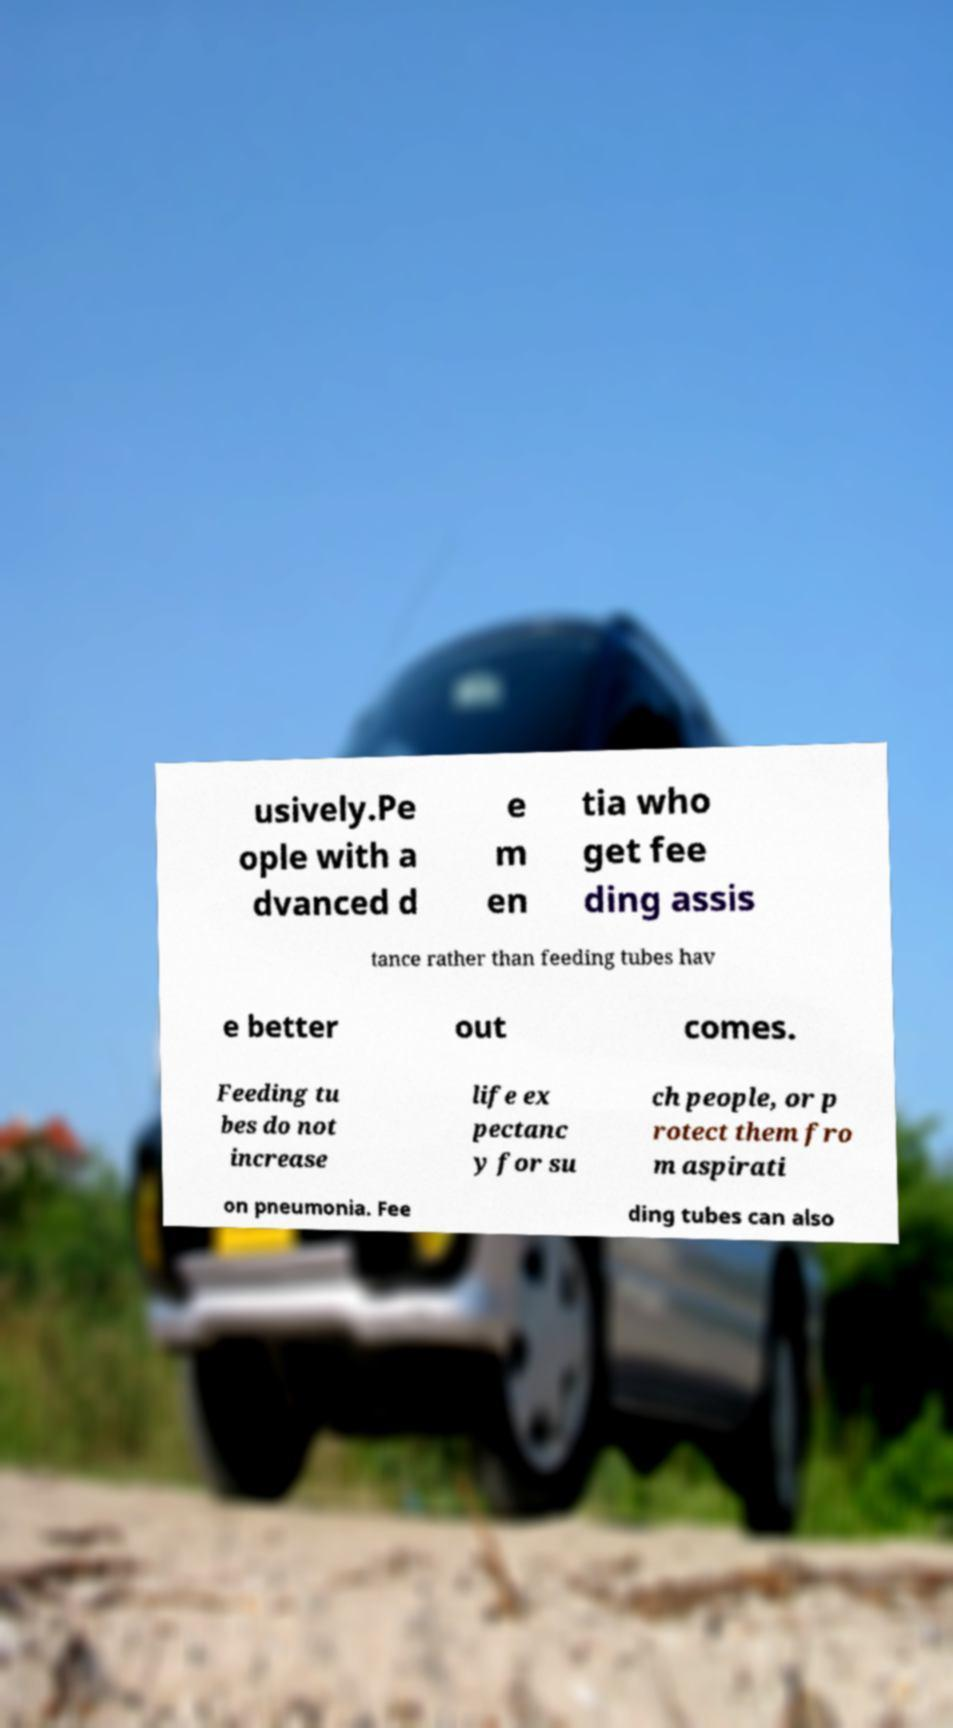Can you accurately transcribe the text from the provided image for me? usively.Pe ople with a dvanced d e m en tia who get fee ding assis tance rather than feeding tubes hav e better out comes. Feeding tu bes do not increase life ex pectanc y for su ch people, or p rotect them fro m aspirati on pneumonia. Fee ding tubes can also 